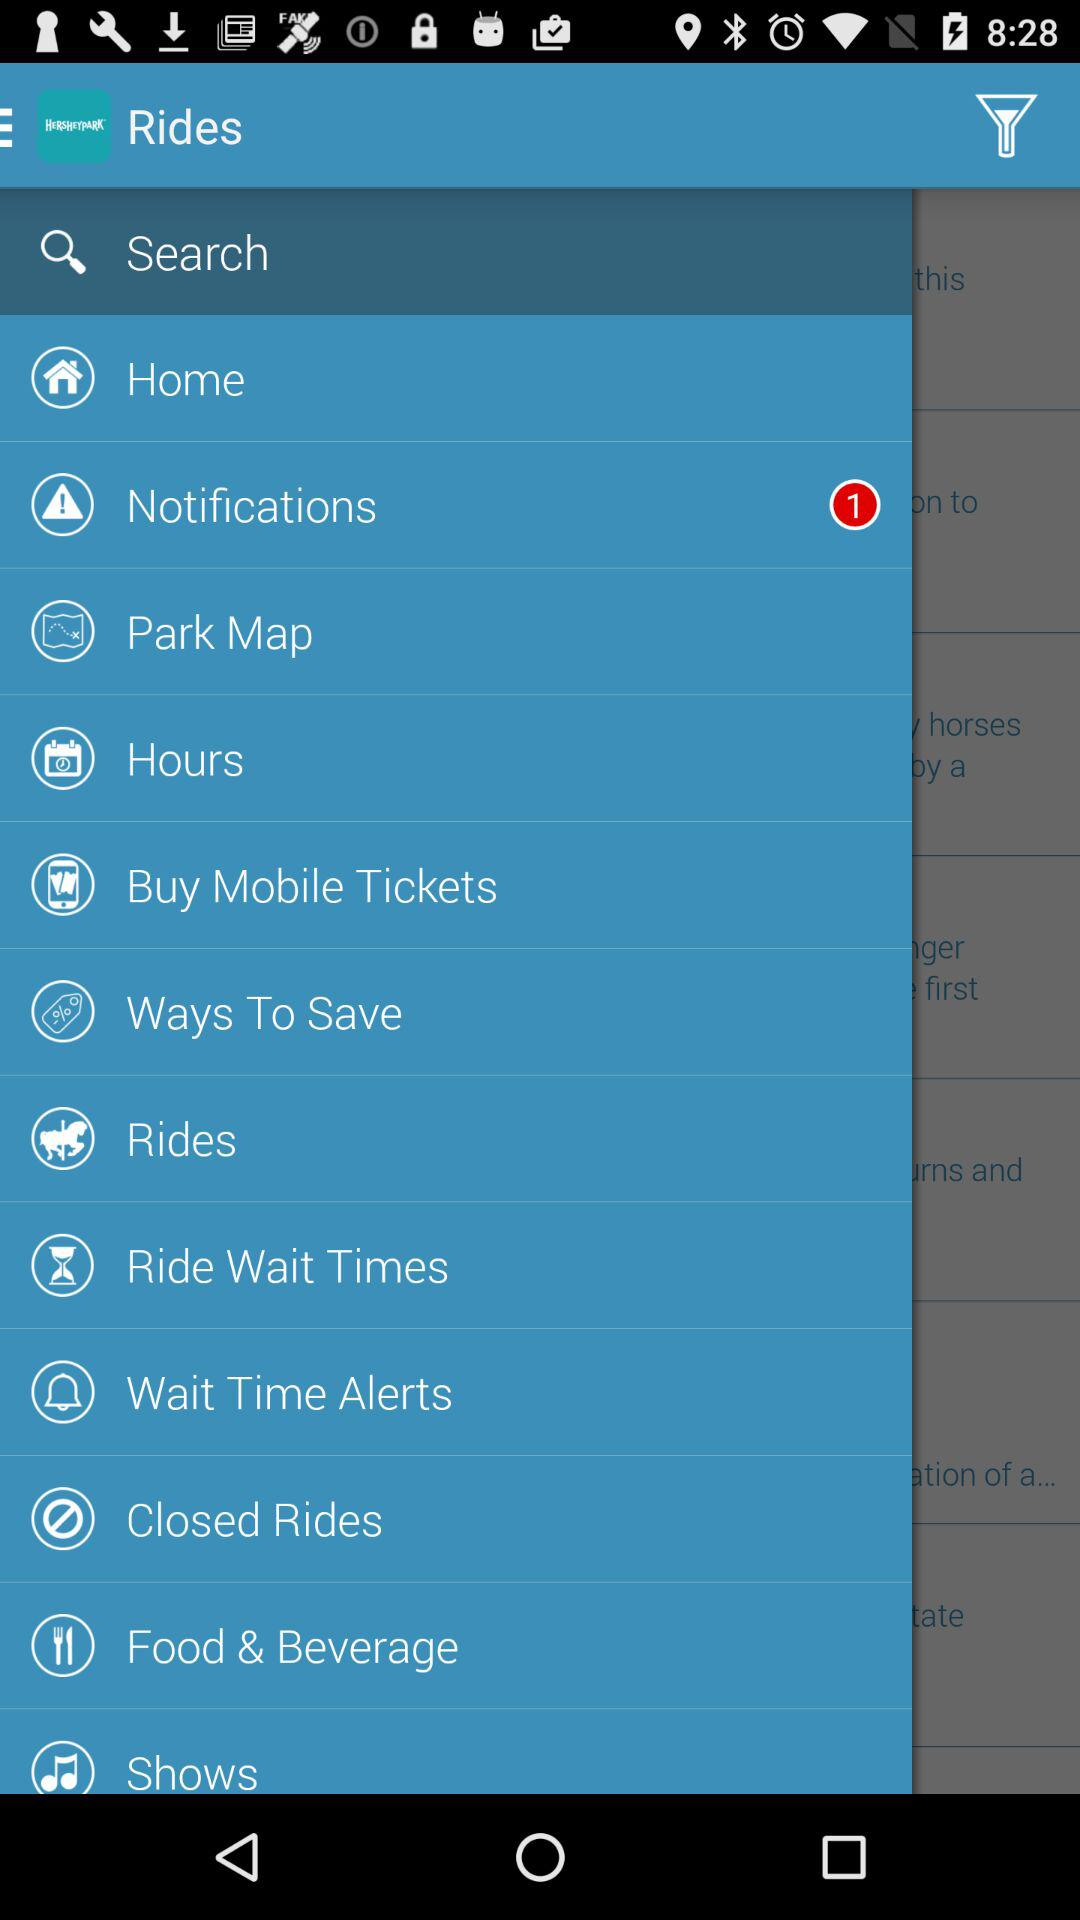How many unread notifications are there? There is one unread notification. 